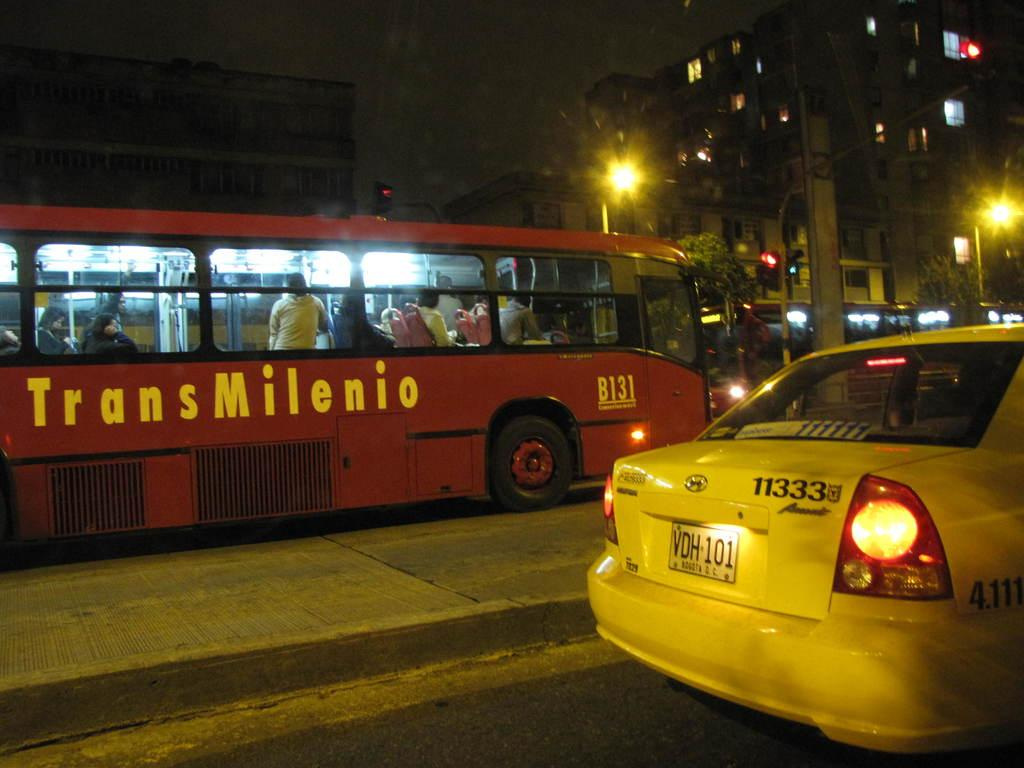<image>
Render a clear and concise summary of the photo. A red bus from TransMilenio on the street at night. 